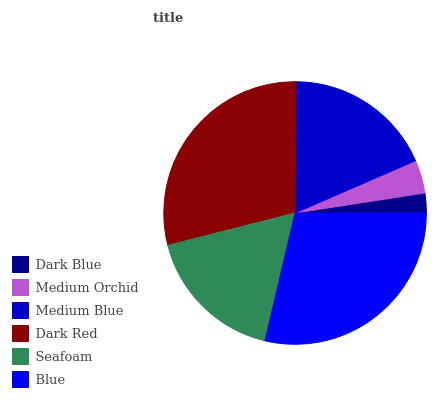Is Dark Blue the minimum?
Answer yes or no. Yes. Is Dark Red the maximum?
Answer yes or no. Yes. Is Medium Orchid the minimum?
Answer yes or no. No. Is Medium Orchid the maximum?
Answer yes or no. No. Is Medium Orchid greater than Dark Blue?
Answer yes or no. Yes. Is Dark Blue less than Medium Orchid?
Answer yes or no. Yes. Is Dark Blue greater than Medium Orchid?
Answer yes or no. No. Is Medium Orchid less than Dark Blue?
Answer yes or no. No. Is Medium Blue the high median?
Answer yes or no. Yes. Is Seafoam the low median?
Answer yes or no. Yes. Is Seafoam the high median?
Answer yes or no. No. Is Medium Orchid the low median?
Answer yes or no. No. 